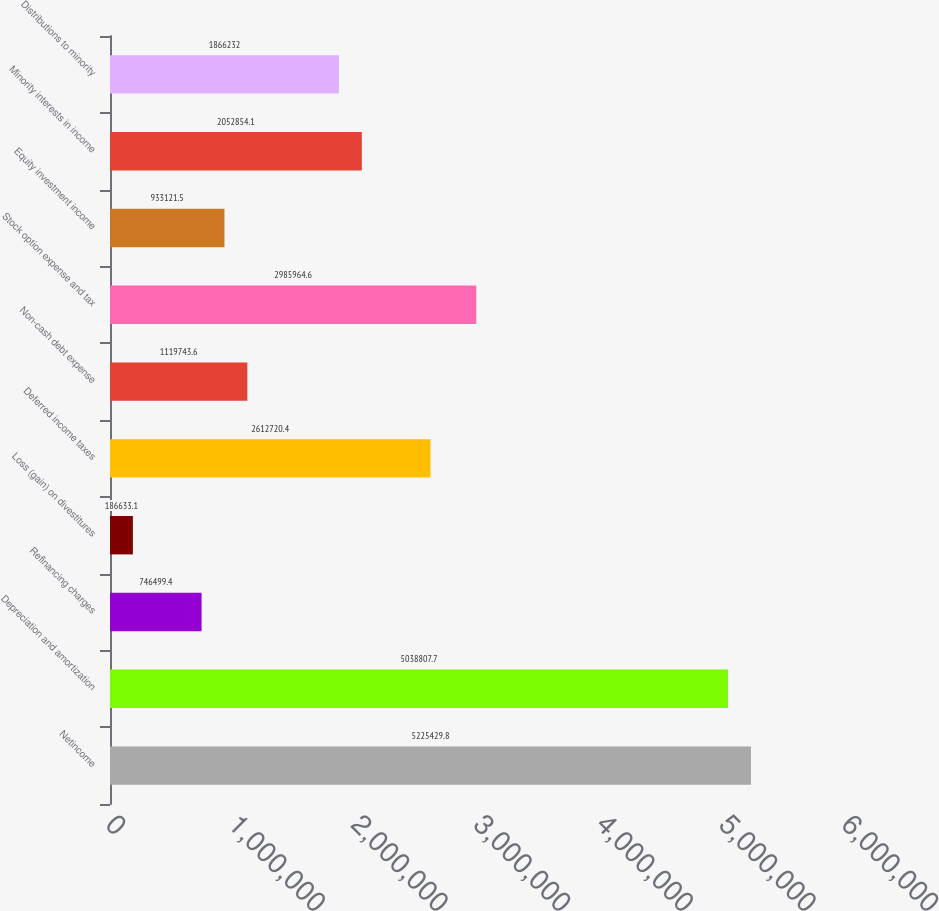Convert chart. <chart><loc_0><loc_0><loc_500><loc_500><bar_chart><fcel>Netincome<fcel>Depreciation and amortization<fcel>Refinancing charges<fcel>Loss (gain) on divestitures<fcel>Deferred income taxes<fcel>Non-cash debt expense<fcel>Stock option expense and tax<fcel>Equity investment income<fcel>Minority interests in income<fcel>Distributions to minority<nl><fcel>5.22543e+06<fcel>5.03881e+06<fcel>746499<fcel>186633<fcel>2.61272e+06<fcel>1.11974e+06<fcel>2.98596e+06<fcel>933122<fcel>2.05285e+06<fcel>1.86623e+06<nl></chart> 